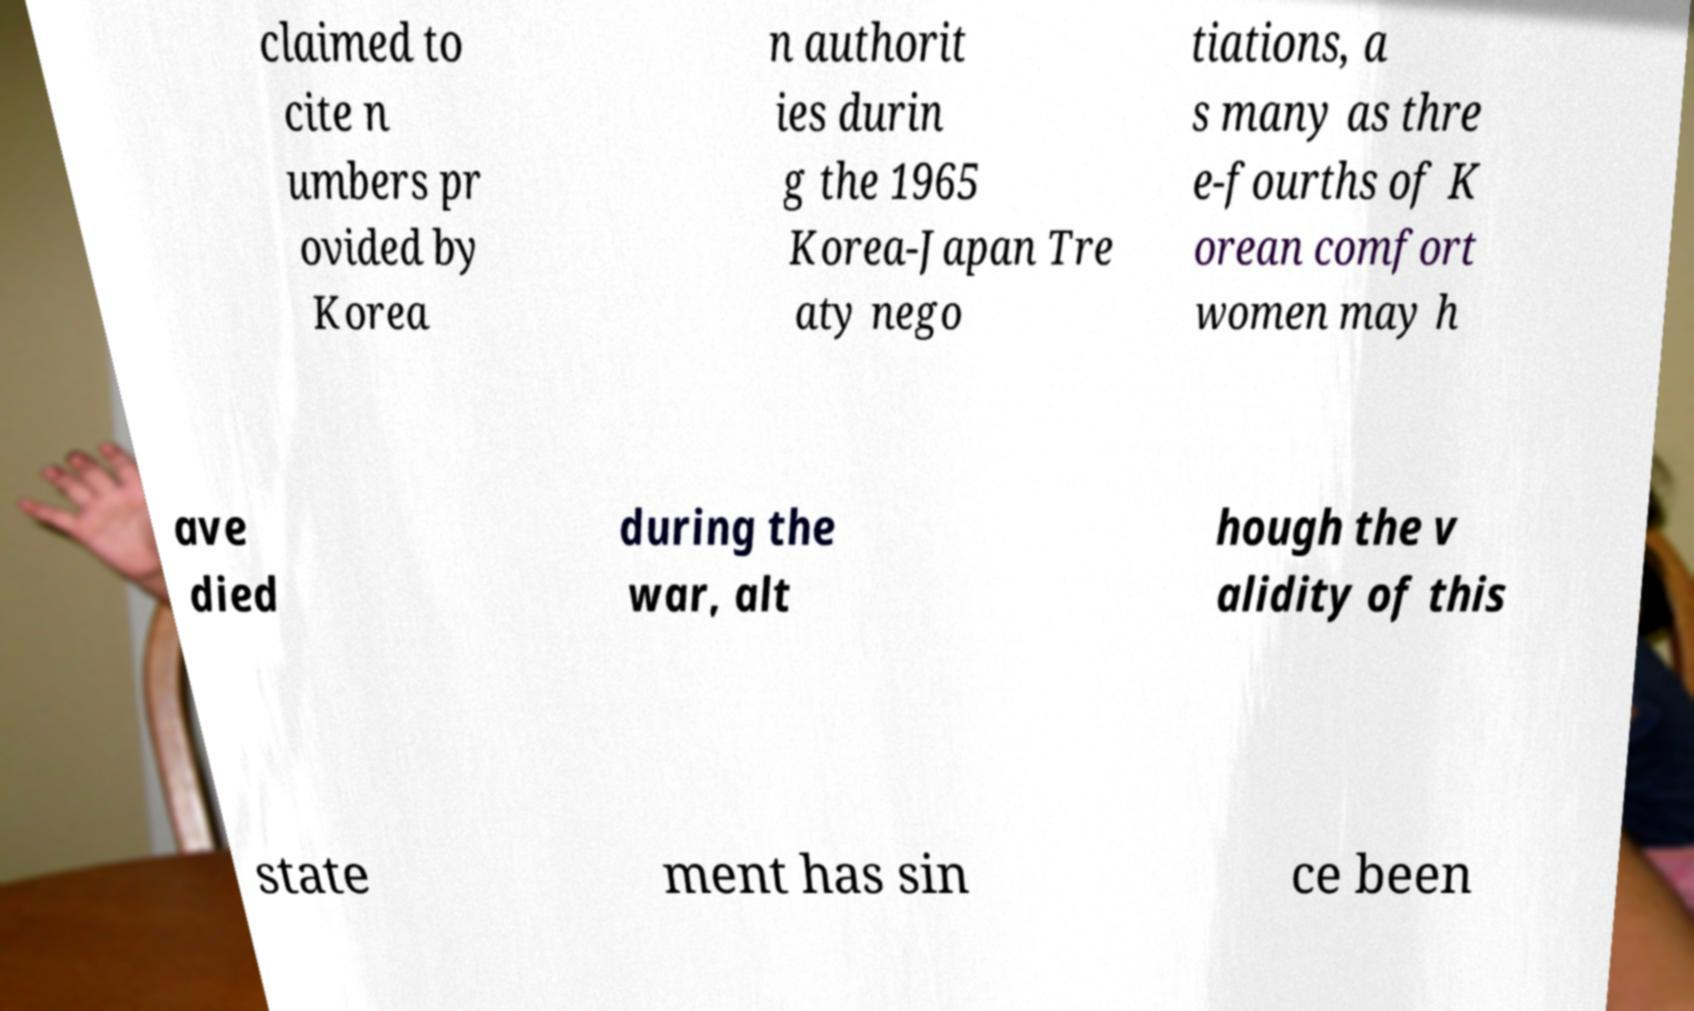There's text embedded in this image that I need extracted. Can you transcribe it verbatim? claimed to cite n umbers pr ovided by Korea n authorit ies durin g the 1965 Korea-Japan Tre aty nego tiations, a s many as thre e-fourths of K orean comfort women may h ave died during the war, alt hough the v alidity of this state ment has sin ce been 